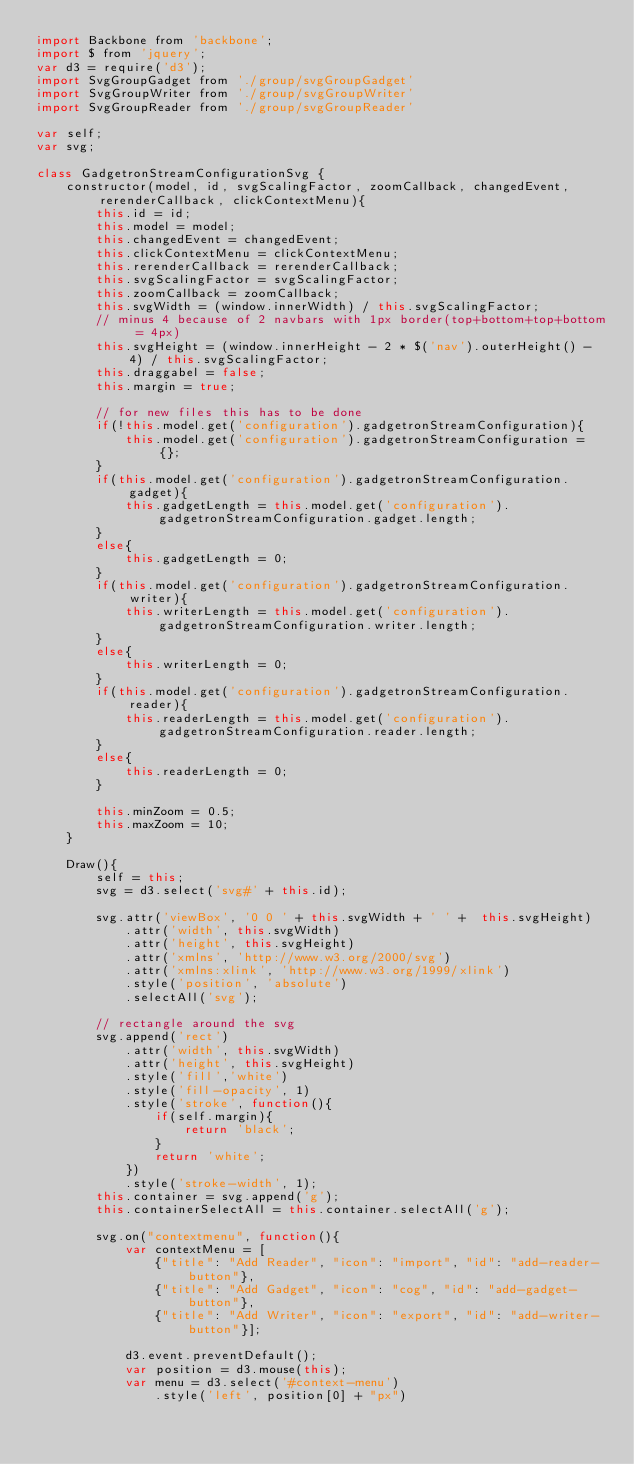<code> <loc_0><loc_0><loc_500><loc_500><_JavaScript_>import Backbone from 'backbone';
import $ from 'jquery';
var d3 = require('d3');
import SvgGroupGadget from './group/svgGroupGadget'
import SvgGroupWriter from './group/svgGroupWriter'
import SvgGroupReader from './group/svgGroupReader'

var self;
var svg;

class GadgetronStreamConfigurationSvg {
    constructor(model, id, svgScalingFactor, zoomCallback, changedEvent, rerenderCallback, clickContextMenu){
        this.id = id;
        this.model = model;
        this.changedEvent = changedEvent;
        this.clickContextMenu = clickContextMenu;
        this.rerenderCallback = rerenderCallback;
        this.svgScalingFactor = svgScalingFactor;
        this.zoomCallback = zoomCallback;
        this.svgWidth = (window.innerWidth) / this.svgScalingFactor;
        // minus 4 because of 2 navbars with 1px border(top+bottom+top+bottom = 4px)
        this.svgHeight = (window.innerHeight - 2 * $('nav').outerHeight() - 4) / this.svgScalingFactor;
        this.draggabel = false;
        this.margin = true;

        // for new files this has to be done
        if(!this.model.get('configuration').gadgetronStreamConfiguration){
            this.model.get('configuration').gadgetronStreamConfiguration = {};
        }
        if(this.model.get('configuration').gadgetronStreamConfiguration.gadget){
            this.gadgetLength = this.model.get('configuration').gadgetronStreamConfiguration.gadget.length;
        }
        else{
            this.gadgetLength = 0;
        }
        if(this.model.get('configuration').gadgetronStreamConfiguration.writer){
            this.writerLength = this.model.get('configuration').gadgetronStreamConfiguration.writer.length;
        }
        else{
            this.writerLength = 0;
        }
        if(this.model.get('configuration').gadgetronStreamConfiguration.reader){
            this.readerLength = this.model.get('configuration').gadgetronStreamConfiguration.reader.length;
        }
        else{
            this.readerLength = 0;
        }

        this.minZoom = 0.5;
        this.maxZoom = 10;
    }

    Draw(){
        self = this;
        svg = d3.select('svg#' + this.id);

        svg.attr('viewBox', '0 0 ' + this.svgWidth + ' ' +  this.svgHeight)
            .attr('width', this.svgWidth)
            .attr('height', this.svgHeight)
            .attr('xmlns', 'http://www.w3.org/2000/svg')
            .attr('xmlns:xlink', 'http://www.w3.org/1999/xlink')
            .style('position', 'absolute')
            .selectAll('svg');

        // rectangle around the svg
        svg.append('rect')
            .attr('width', this.svgWidth)
            .attr('height', this.svgHeight)
            .style('fill','white')
            .style('fill-opacity', 1)
            .style('stroke', function(){
                if(self.margin){
                    return 'black';
                }
                return 'white';
            })
            .style('stroke-width', 1);
        this.container = svg.append('g');
        this.containerSelectAll = this.container.selectAll('g');

        svg.on("contextmenu", function(){
            var contextMenu = [
                {"title": "Add Reader", "icon": "import", "id": "add-reader-button"},
                {"title": "Add Gadget", "icon": "cog", "id": "add-gadget-button"},
                {"title": "Add Writer", "icon": "export", "id": "add-writer-button"}];

            d3.event.preventDefault();
            var position = d3.mouse(this);
            var menu = d3.select('#context-menu')
                .style('left', position[0] + "px")</code> 